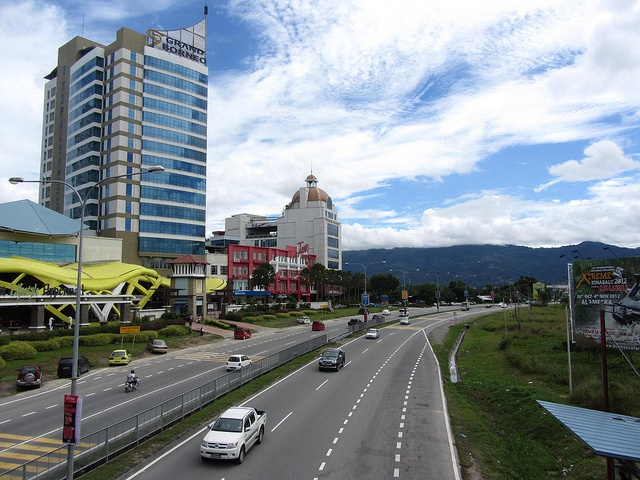Describe the objects in this image and their specific colors. I can see car in lightblue, black, gray, and darkgreen tones, truck in lightblue, lightgray, gray, darkgray, and black tones, truck in lightblue, gray, black, and darkgray tones, car in lightblue, black, gray, and darkgray tones, and car in lightblue, darkgray, black, gray, and lightgray tones in this image. 